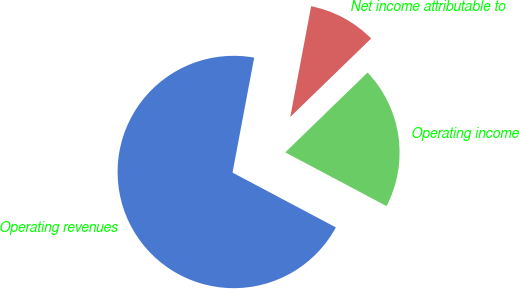<chart> <loc_0><loc_0><loc_500><loc_500><pie_chart><fcel>Operating revenues<fcel>Operating income<fcel>Net income attributable to<nl><fcel>70.2%<fcel>20.02%<fcel>9.78%<nl></chart> 